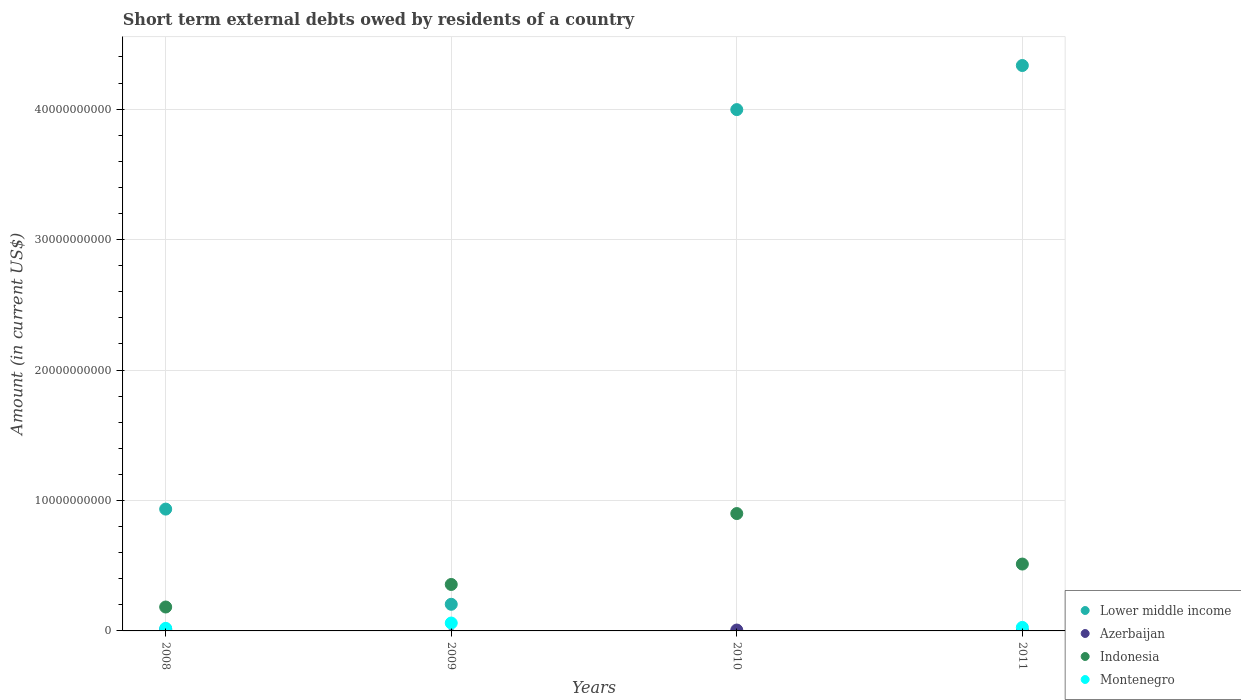Is the number of dotlines equal to the number of legend labels?
Keep it short and to the point. No. What is the amount of short-term external debts owed by residents in Lower middle income in 2010?
Offer a terse response. 4.00e+1. Across all years, what is the maximum amount of short-term external debts owed by residents in Indonesia?
Offer a very short reply. 9.00e+09. Across all years, what is the minimum amount of short-term external debts owed by residents in Indonesia?
Your response must be concise. 1.83e+09. In which year was the amount of short-term external debts owed by residents in Montenegro maximum?
Give a very brief answer. 2009. What is the total amount of short-term external debts owed by residents in Indonesia in the graph?
Give a very brief answer. 1.95e+1. What is the difference between the amount of short-term external debts owed by residents in Montenegro in 2008 and that in 2011?
Your answer should be very brief. -7.20e+07. What is the difference between the amount of short-term external debts owed by residents in Montenegro in 2008 and the amount of short-term external debts owed by residents in Lower middle income in 2009?
Ensure brevity in your answer.  -1.84e+09. What is the average amount of short-term external debts owed by residents in Montenegro per year?
Offer a very short reply. 2.68e+08. In the year 2008, what is the difference between the amount of short-term external debts owed by residents in Lower middle income and amount of short-term external debts owed by residents in Montenegro?
Your answer should be very brief. 9.14e+09. What is the ratio of the amount of short-term external debts owed by residents in Indonesia in 2009 to that in 2010?
Keep it short and to the point. 0.4. Is the amount of short-term external debts owed by residents in Indonesia in 2010 less than that in 2011?
Offer a very short reply. No. What is the difference between the highest and the second highest amount of short-term external debts owed by residents in Lower middle income?
Your answer should be compact. 3.38e+09. What is the difference between the highest and the lowest amount of short-term external debts owed by residents in Lower middle income?
Provide a short and direct response. 4.13e+1. Is the sum of the amount of short-term external debts owed by residents in Lower middle income in 2008 and 2009 greater than the maximum amount of short-term external debts owed by residents in Indonesia across all years?
Offer a very short reply. Yes. Is it the case that in every year, the sum of the amount of short-term external debts owed by residents in Montenegro and amount of short-term external debts owed by residents in Azerbaijan  is greater than the amount of short-term external debts owed by residents in Lower middle income?
Keep it short and to the point. No. Does the amount of short-term external debts owed by residents in Azerbaijan monotonically increase over the years?
Your answer should be compact. No. Is the amount of short-term external debts owed by residents in Montenegro strictly less than the amount of short-term external debts owed by residents in Azerbaijan over the years?
Your response must be concise. No. What is the difference between two consecutive major ticks on the Y-axis?
Your answer should be compact. 1.00e+1. Are the values on the major ticks of Y-axis written in scientific E-notation?
Your response must be concise. No. Where does the legend appear in the graph?
Keep it short and to the point. Bottom right. How many legend labels are there?
Offer a very short reply. 4. How are the legend labels stacked?
Your response must be concise. Vertical. What is the title of the graph?
Ensure brevity in your answer.  Short term external debts owed by residents of a country. Does "Oman" appear as one of the legend labels in the graph?
Provide a succinct answer. No. What is the Amount (in current US$) in Lower middle income in 2008?
Offer a very short reply. 9.34e+09. What is the Amount (in current US$) of Azerbaijan in 2008?
Keep it short and to the point. 1.26e+08. What is the Amount (in current US$) in Indonesia in 2008?
Offer a terse response. 1.83e+09. What is the Amount (in current US$) in Montenegro in 2008?
Give a very brief answer. 1.97e+08. What is the Amount (in current US$) of Lower middle income in 2009?
Your response must be concise. 2.04e+09. What is the Amount (in current US$) of Azerbaijan in 2009?
Your response must be concise. 0. What is the Amount (in current US$) in Indonesia in 2009?
Your answer should be compact. 3.56e+09. What is the Amount (in current US$) in Montenegro in 2009?
Offer a very short reply. 6.05e+08. What is the Amount (in current US$) of Lower middle income in 2010?
Your response must be concise. 4.00e+1. What is the Amount (in current US$) in Azerbaijan in 2010?
Make the answer very short. 6.80e+07. What is the Amount (in current US$) in Indonesia in 2010?
Offer a terse response. 9.00e+09. What is the Amount (in current US$) of Lower middle income in 2011?
Provide a short and direct response. 4.33e+1. What is the Amount (in current US$) of Azerbaijan in 2011?
Your answer should be very brief. 1.30e+07. What is the Amount (in current US$) of Indonesia in 2011?
Offer a very short reply. 5.13e+09. What is the Amount (in current US$) of Montenegro in 2011?
Make the answer very short. 2.69e+08. Across all years, what is the maximum Amount (in current US$) in Lower middle income?
Give a very brief answer. 4.33e+1. Across all years, what is the maximum Amount (in current US$) in Azerbaijan?
Your response must be concise. 1.26e+08. Across all years, what is the maximum Amount (in current US$) of Indonesia?
Your answer should be very brief. 9.00e+09. Across all years, what is the maximum Amount (in current US$) of Montenegro?
Ensure brevity in your answer.  6.05e+08. Across all years, what is the minimum Amount (in current US$) in Lower middle income?
Give a very brief answer. 2.04e+09. Across all years, what is the minimum Amount (in current US$) in Azerbaijan?
Ensure brevity in your answer.  0. Across all years, what is the minimum Amount (in current US$) in Indonesia?
Give a very brief answer. 1.83e+09. Across all years, what is the minimum Amount (in current US$) in Montenegro?
Your response must be concise. 0. What is the total Amount (in current US$) of Lower middle income in the graph?
Offer a very short reply. 9.47e+1. What is the total Amount (in current US$) in Azerbaijan in the graph?
Your answer should be very brief. 2.07e+08. What is the total Amount (in current US$) in Indonesia in the graph?
Your response must be concise. 1.95e+1. What is the total Amount (in current US$) of Montenegro in the graph?
Offer a terse response. 1.07e+09. What is the difference between the Amount (in current US$) in Lower middle income in 2008 and that in 2009?
Offer a terse response. 7.30e+09. What is the difference between the Amount (in current US$) in Indonesia in 2008 and that in 2009?
Offer a very short reply. -1.73e+09. What is the difference between the Amount (in current US$) of Montenegro in 2008 and that in 2009?
Provide a succinct answer. -4.08e+08. What is the difference between the Amount (in current US$) of Lower middle income in 2008 and that in 2010?
Your response must be concise. -3.06e+1. What is the difference between the Amount (in current US$) of Azerbaijan in 2008 and that in 2010?
Give a very brief answer. 5.80e+07. What is the difference between the Amount (in current US$) of Indonesia in 2008 and that in 2010?
Offer a terse response. -7.16e+09. What is the difference between the Amount (in current US$) of Lower middle income in 2008 and that in 2011?
Make the answer very short. -3.40e+1. What is the difference between the Amount (in current US$) of Azerbaijan in 2008 and that in 2011?
Provide a short and direct response. 1.13e+08. What is the difference between the Amount (in current US$) of Indonesia in 2008 and that in 2011?
Offer a terse response. -3.29e+09. What is the difference between the Amount (in current US$) of Montenegro in 2008 and that in 2011?
Your answer should be compact. -7.20e+07. What is the difference between the Amount (in current US$) in Lower middle income in 2009 and that in 2010?
Offer a terse response. -3.79e+1. What is the difference between the Amount (in current US$) of Indonesia in 2009 and that in 2010?
Provide a succinct answer. -5.44e+09. What is the difference between the Amount (in current US$) in Lower middle income in 2009 and that in 2011?
Your response must be concise. -4.13e+1. What is the difference between the Amount (in current US$) in Indonesia in 2009 and that in 2011?
Your answer should be compact. -1.56e+09. What is the difference between the Amount (in current US$) in Montenegro in 2009 and that in 2011?
Keep it short and to the point. 3.36e+08. What is the difference between the Amount (in current US$) in Lower middle income in 2010 and that in 2011?
Offer a very short reply. -3.38e+09. What is the difference between the Amount (in current US$) of Azerbaijan in 2010 and that in 2011?
Your answer should be very brief. 5.50e+07. What is the difference between the Amount (in current US$) of Indonesia in 2010 and that in 2011?
Give a very brief answer. 3.87e+09. What is the difference between the Amount (in current US$) in Lower middle income in 2008 and the Amount (in current US$) in Indonesia in 2009?
Offer a terse response. 5.78e+09. What is the difference between the Amount (in current US$) in Lower middle income in 2008 and the Amount (in current US$) in Montenegro in 2009?
Give a very brief answer. 8.73e+09. What is the difference between the Amount (in current US$) in Azerbaijan in 2008 and the Amount (in current US$) in Indonesia in 2009?
Your answer should be very brief. -3.44e+09. What is the difference between the Amount (in current US$) of Azerbaijan in 2008 and the Amount (in current US$) of Montenegro in 2009?
Offer a terse response. -4.79e+08. What is the difference between the Amount (in current US$) of Indonesia in 2008 and the Amount (in current US$) of Montenegro in 2009?
Your answer should be compact. 1.23e+09. What is the difference between the Amount (in current US$) in Lower middle income in 2008 and the Amount (in current US$) in Azerbaijan in 2010?
Ensure brevity in your answer.  9.27e+09. What is the difference between the Amount (in current US$) in Lower middle income in 2008 and the Amount (in current US$) in Indonesia in 2010?
Your answer should be very brief. 3.42e+08. What is the difference between the Amount (in current US$) of Azerbaijan in 2008 and the Amount (in current US$) of Indonesia in 2010?
Ensure brevity in your answer.  -8.87e+09. What is the difference between the Amount (in current US$) of Lower middle income in 2008 and the Amount (in current US$) of Azerbaijan in 2011?
Ensure brevity in your answer.  9.33e+09. What is the difference between the Amount (in current US$) in Lower middle income in 2008 and the Amount (in current US$) in Indonesia in 2011?
Provide a short and direct response. 4.21e+09. What is the difference between the Amount (in current US$) of Lower middle income in 2008 and the Amount (in current US$) of Montenegro in 2011?
Give a very brief answer. 9.07e+09. What is the difference between the Amount (in current US$) in Azerbaijan in 2008 and the Amount (in current US$) in Indonesia in 2011?
Your response must be concise. -5.00e+09. What is the difference between the Amount (in current US$) in Azerbaijan in 2008 and the Amount (in current US$) in Montenegro in 2011?
Ensure brevity in your answer.  -1.43e+08. What is the difference between the Amount (in current US$) in Indonesia in 2008 and the Amount (in current US$) in Montenegro in 2011?
Ensure brevity in your answer.  1.56e+09. What is the difference between the Amount (in current US$) in Lower middle income in 2009 and the Amount (in current US$) in Azerbaijan in 2010?
Make the answer very short. 1.97e+09. What is the difference between the Amount (in current US$) in Lower middle income in 2009 and the Amount (in current US$) in Indonesia in 2010?
Make the answer very short. -6.96e+09. What is the difference between the Amount (in current US$) of Lower middle income in 2009 and the Amount (in current US$) of Azerbaijan in 2011?
Make the answer very short. 2.03e+09. What is the difference between the Amount (in current US$) of Lower middle income in 2009 and the Amount (in current US$) of Indonesia in 2011?
Keep it short and to the point. -3.08e+09. What is the difference between the Amount (in current US$) of Lower middle income in 2009 and the Amount (in current US$) of Montenegro in 2011?
Your answer should be compact. 1.77e+09. What is the difference between the Amount (in current US$) of Indonesia in 2009 and the Amount (in current US$) of Montenegro in 2011?
Provide a succinct answer. 3.29e+09. What is the difference between the Amount (in current US$) in Lower middle income in 2010 and the Amount (in current US$) in Azerbaijan in 2011?
Keep it short and to the point. 4.00e+1. What is the difference between the Amount (in current US$) in Lower middle income in 2010 and the Amount (in current US$) in Indonesia in 2011?
Your answer should be very brief. 3.48e+1. What is the difference between the Amount (in current US$) in Lower middle income in 2010 and the Amount (in current US$) in Montenegro in 2011?
Offer a very short reply. 3.97e+1. What is the difference between the Amount (in current US$) of Azerbaijan in 2010 and the Amount (in current US$) of Indonesia in 2011?
Provide a short and direct response. -5.06e+09. What is the difference between the Amount (in current US$) of Azerbaijan in 2010 and the Amount (in current US$) of Montenegro in 2011?
Your response must be concise. -2.01e+08. What is the difference between the Amount (in current US$) in Indonesia in 2010 and the Amount (in current US$) in Montenegro in 2011?
Offer a very short reply. 8.73e+09. What is the average Amount (in current US$) in Lower middle income per year?
Give a very brief answer. 2.37e+1. What is the average Amount (in current US$) of Azerbaijan per year?
Keep it short and to the point. 5.18e+07. What is the average Amount (in current US$) in Indonesia per year?
Offer a terse response. 4.88e+09. What is the average Amount (in current US$) in Montenegro per year?
Ensure brevity in your answer.  2.68e+08. In the year 2008, what is the difference between the Amount (in current US$) of Lower middle income and Amount (in current US$) of Azerbaijan?
Offer a terse response. 9.21e+09. In the year 2008, what is the difference between the Amount (in current US$) in Lower middle income and Amount (in current US$) in Indonesia?
Your response must be concise. 7.51e+09. In the year 2008, what is the difference between the Amount (in current US$) of Lower middle income and Amount (in current US$) of Montenegro?
Keep it short and to the point. 9.14e+09. In the year 2008, what is the difference between the Amount (in current US$) in Azerbaijan and Amount (in current US$) in Indonesia?
Keep it short and to the point. -1.71e+09. In the year 2008, what is the difference between the Amount (in current US$) in Azerbaijan and Amount (in current US$) in Montenegro?
Give a very brief answer. -7.10e+07. In the year 2008, what is the difference between the Amount (in current US$) in Indonesia and Amount (in current US$) in Montenegro?
Give a very brief answer. 1.64e+09. In the year 2009, what is the difference between the Amount (in current US$) in Lower middle income and Amount (in current US$) in Indonesia?
Your answer should be very brief. -1.52e+09. In the year 2009, what is the difference between the Amount (in current US$) of Lower middle income and Amount (in current US$) of Montenegro?
Ensure brevity in your answer.  1.44e+09. In the year 2009, what is the difference between the Amount (in current US$) of Indonesia and Amount (in current US$) of Montenegro?
Give a very brief answer. 2.96e+09. In the year 2010, what is the difference between the Amount (in current US$) in Lower middle income and Amount (in current US$) in Azerbaijan?
Your answer should be very brief. 3.99e+1. In the year 2010, what is the difference between the Amount (in current US$) of Lower middle income and Amount (in current US$) of Indonesia?
Your answer should be compact. 3.10e+1. In the year 2010, what is the difference between the Amount (in current US$) of Azerbaijan and Amount (in current US$) of Indonesia?
Keep it short and to the point. -8.93e+09. In the year 2011, what is the difference between the Amount (in current US$) of Lower middle income and Amount (in current US$) of Azerbaijan?
Your response must be concise. 4.33e+1. In the year 2011, what is the difference between the Amount (in current US$) of Lower middle income and Amount (in current US$) of Indonesia?
Give a very brief answer. 3.82e+1. In the year 2011, what is the difference between the Amount (in current US$) of Lower middle income and Amount (in current US$) of Montenegro?
Provide a succinct answer. 4.31e+1. In the year 2011, what is the difference between the Amount (in current US$) in Azerbaijan and Amount (in current US$) in Indonesia?
Provide a succinct answer. -5.11e+09. In the year 2011, what is the difference between the Amount (in current US$) in Azerbaijan and Amount (in current US$) in Montenegro?
Make the answer very short. -2.56e+08. In the year 2011, what is the difference between the Amount (in current US$) of Indonesia and Amount (in current US$) of Montenegro?
Your response must be concise. 4.86e+09. What is the ratio of the Amount (in current US$) of Lower middle income in 2008 to that in 2009?
Ensure brevity in your answer.  4.58. What is the ratio of the Amount (in current US$) of Indonesia in 2008 to that in 2009?
Make the answer very short. 0.51. What is the ratio of the Amount (in current US$) of Montenegro in 2008 to that in 2009?
Ensure brevity in your answer.  0.33. What is the ratio of the Amount (in current US$) in Lower middle income in 2008 to that in 2010?
Offer a terse response. 0.23. What is the ratio of the Amount (in current US$) of Azerbaijan in 2008 to that in 2010?
Provide a succinct answer. 1.85. What is the ratio of the Amount (in current US$) in Indonesia in 2008 to that in 2010?
Ensure brevity in your answer.  0.2. What is the ratio of the Amount (in current US$) of Lower middle income in 2008 to that in 2011?
Provide a short and direct response. 0.22. What is the ratio of the Amount (in current US$) in Azerbaijan in 2008 to that in 2011?
Give a very brief answer. 9.69. What is the ratio of the Amount (in current US$) of Indonesia in 2008 to that in 2011?
Provide a succinct answer. 0.36. What is the ratio of the Amount (in current US$) of Montenegro in 2008 to that in 2011?
Give a very brief answer. 0.73. What is the ratio of the Amount (in current US$) of Lower middle income in 2009 to that in 2010?
Your answer should be very brief. 0.05. What is the ratio of the Amount (in current US$) in Indonesia in 2009 to that in 2010?
Your answer should be very brief. 0.4. What is the ratio of the Amount (in current US$) of Lower middle income in 2009 to that in 2011?
Keep it short and to the point. 0.05. What is the ratio of the Amount (in current US$) of Indonesia in 2009 to that in 2011?
Make the answer very short. 0.69. What is the ratio of the Amount (in current US$) of Montenegro in 2009 to that in 2011?
Make the answer very short. 2.25. What is the ratio of the Amount (in current US$) of Lower middle income in 2010 to that in 2011?
Provide a succinct answer. 0.92. What is the ratio of the Amount (in current US$) of Azerbaijan in 2010 to that in 2011?
Your answer should be very brief. 5.23. What is the ratio of the Amount (in current US$) of Indonesia in 2010 to that in 2011?
Ensure brevity in your answer.  1.76. What is the difference between the highest and the second highest Amount (in current US$) of Lower middle income?
Your answer should be very brief. 3.38e+09. What is the difference between the highest and the second highest Amount (in current US$) of Azerbaijan?
Provide a succinct answer. 5.80e+07. What is the difference between the highest and the second highest Amount (in current US$) of Indonesia?
Your response must be concise. 3.87e+09. What is the difference between the highest and the second highest Amount (in current US$) of Montenegro?
Provide a short and direct response. 3.36e+08. What is the difference between the highest and the lowest Amount (in current US$) of Lower middle income?
Offer a terse response. 4.13e+1. What is the difference between the highest and the lowest Amount (in current US$) of Azerbaijan?
Provide a succinct answer. 1.26e+08. What is the difference between the highest and the lowest Amount (in current US$) in Indonesia?
Offer a very short reply. 7.16e+09. What is the difference between the highest and the lowest Amount (in current US$) in Montenegro?
Provide a short and direct response. 6.05e+08. 